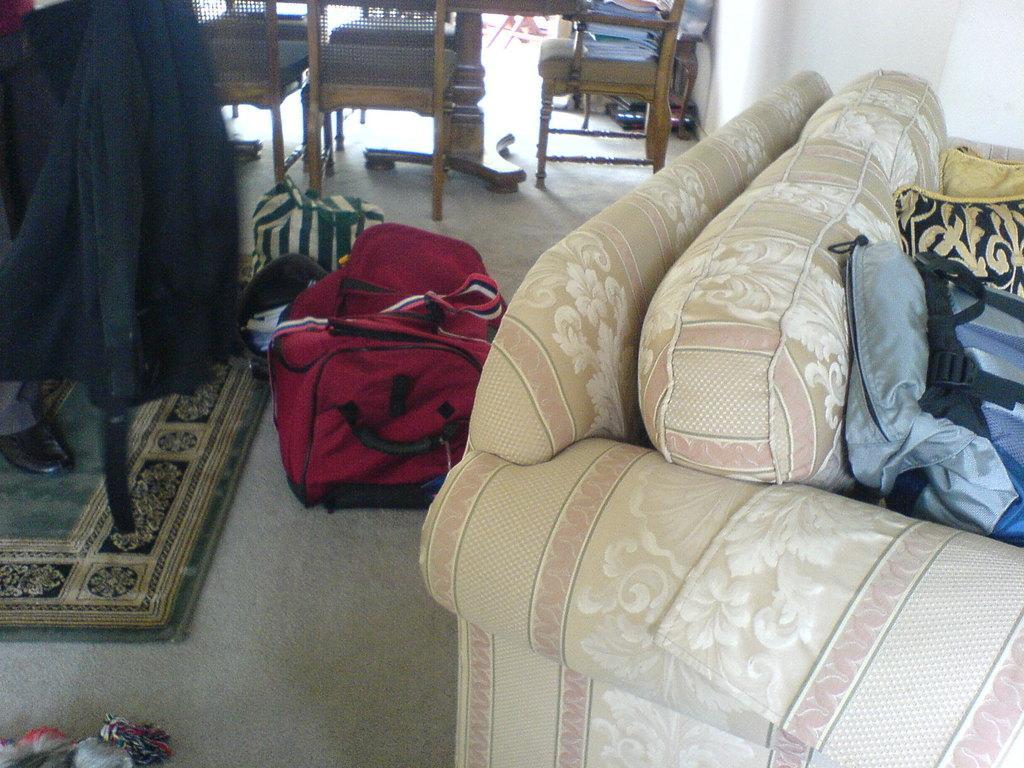In one or two sentences, can you explain what this image depicts? This is the picture taken in a room, on the floor there are mat, chairs, bags and a sofa. Behind the sofa there's a wall. 